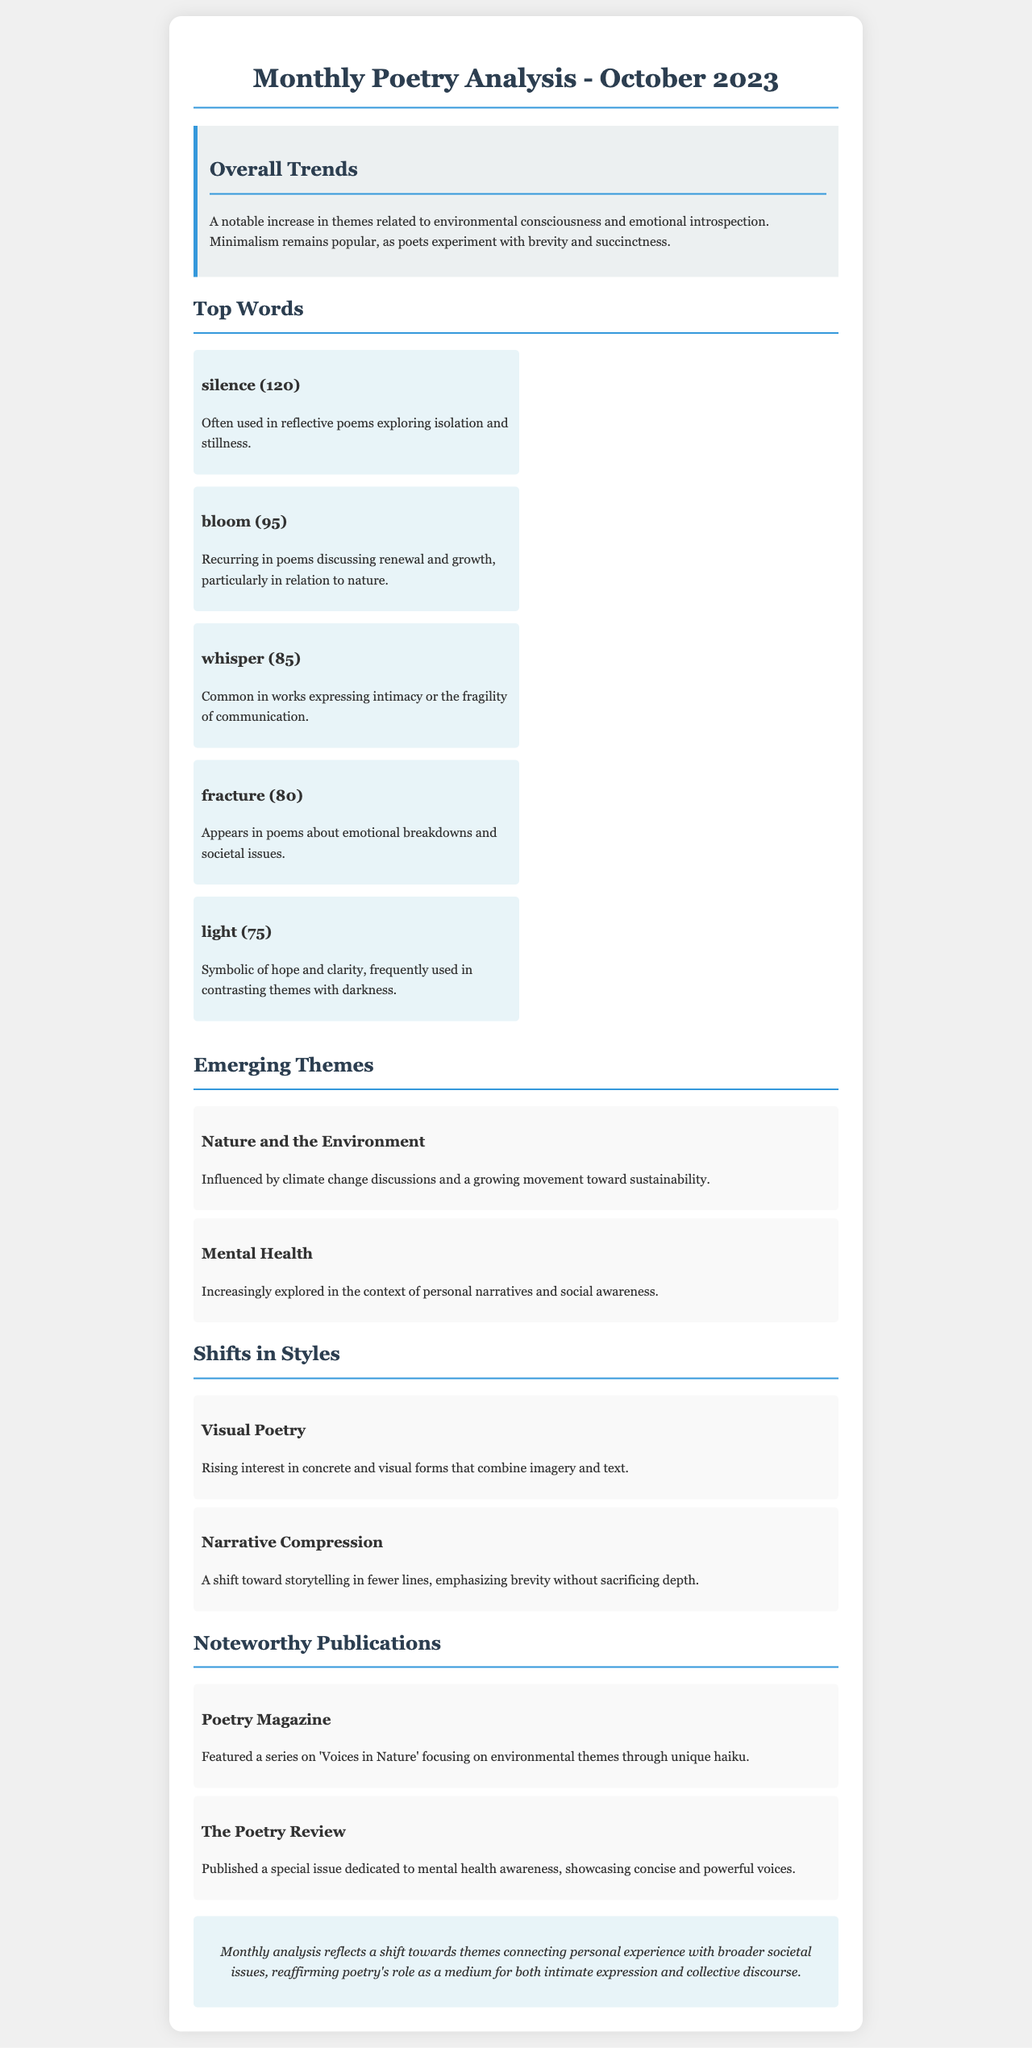What are the top themes in October 2023? The report identifies key themes such as nature and the environment, and mental health as significant in this month's poetry analysis.
Answer: nature and the environment, mental health How many times was the word "silence" used? The document states the usage frequency of specific words, with "silence" noted for its prominence in reflective poems.
Answer: 120 Which publication focused on environmental themes? Noteworthy publications are highlighted, with one specifically featuring environmental topics in a series.
Answer: Poetry Magazine What style is rising in popularity? The document captures shifts in poetic styles, including the emergence of visual poetry.
Answer: Visual Poetry What do poets experiment with according to the summary? The overall trends section indicates a trend where poets are experimenting with a particular concept.
Answer: brevity and succinctness What word appears in poems about emotional breakdowns? The report includes specific words that have thematic relevance, where one pertains to emotional struggles.
Answer: fracture What is the focus of The Poetry Review's special issue? The document details the spotlight of various publications, particularly mentioning a themed issue focusing on a specific social concern.
Answer: mental health awareness How does the analysis characterize poetry's role? The conclusion summarizes the document's perspective on the significance of poetry in addressing both personal and societal matters.
Answer: medium for both intimate expression and collective discourse 